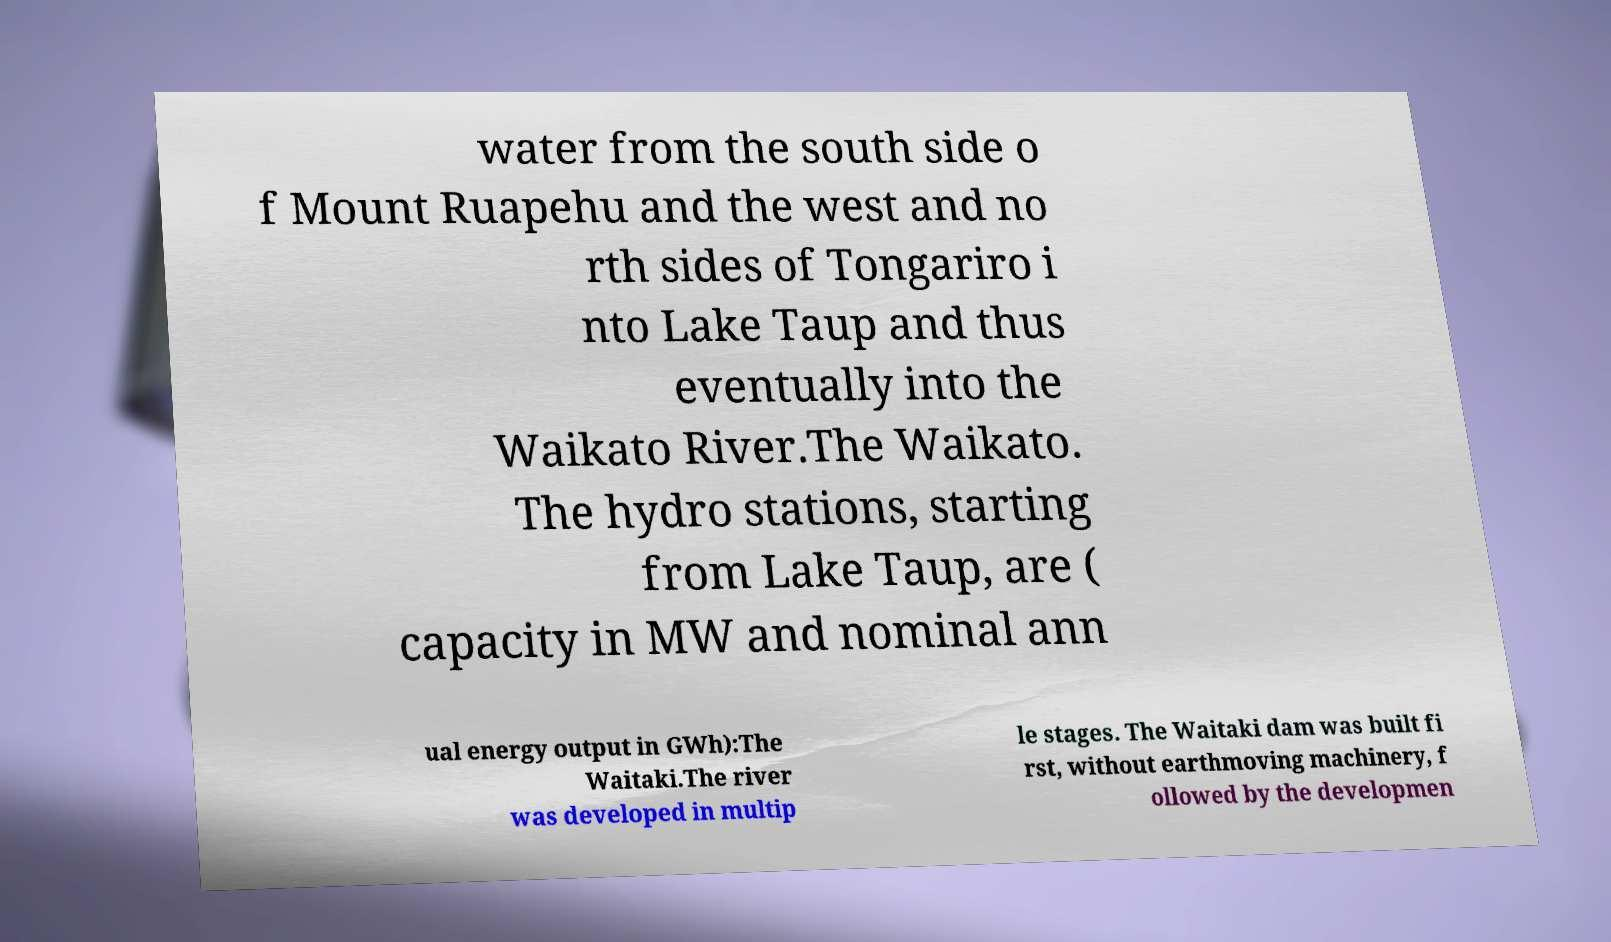For documentation purposes, I need the text within this image transcribed. Could you provide that? water from the south side o f Mount Ruapehu and the west and no rth sides of Tongariro i nto Lake Taup and thus eventually into the Waikato River.The Waikato. The hydro stations, starting from Lake Taup, are ( capacity in MW and nominal ann ual energy output in GWh):The Waitaki.The river was developed in multip le stages. The Waitaki dam was built fi rst, without earthmoving machinery, f ollowed by the developmen 